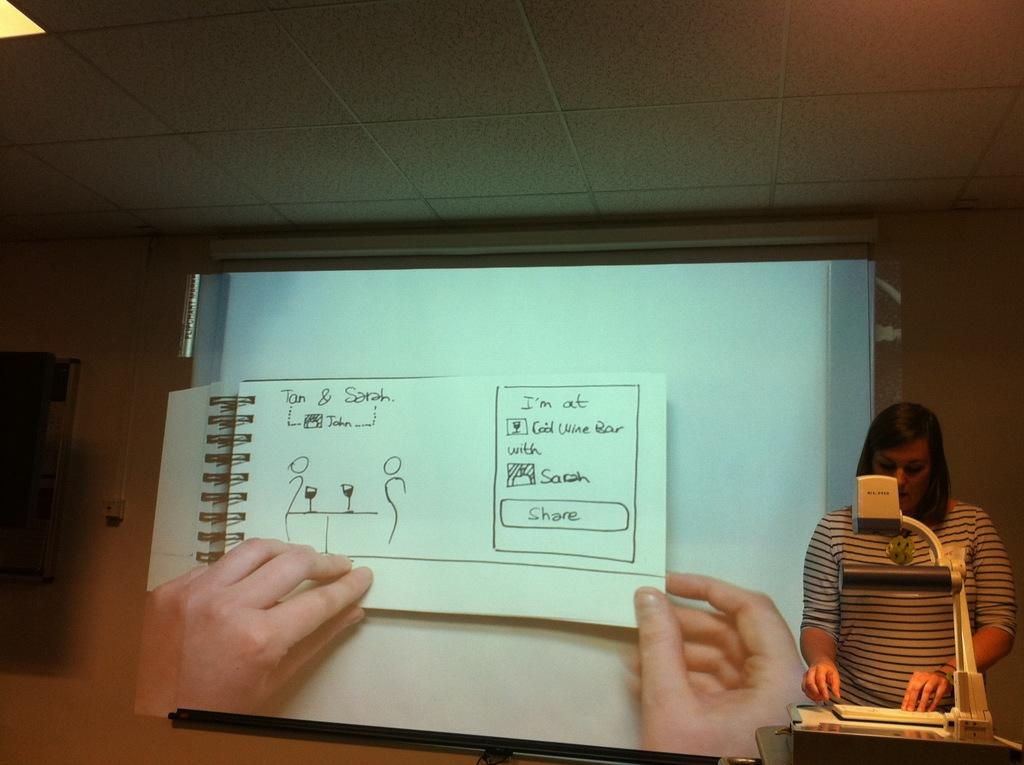<image>
Present a compact description of the photo's key features. A drawing of Tan and Sarah is being shown on a projector. 